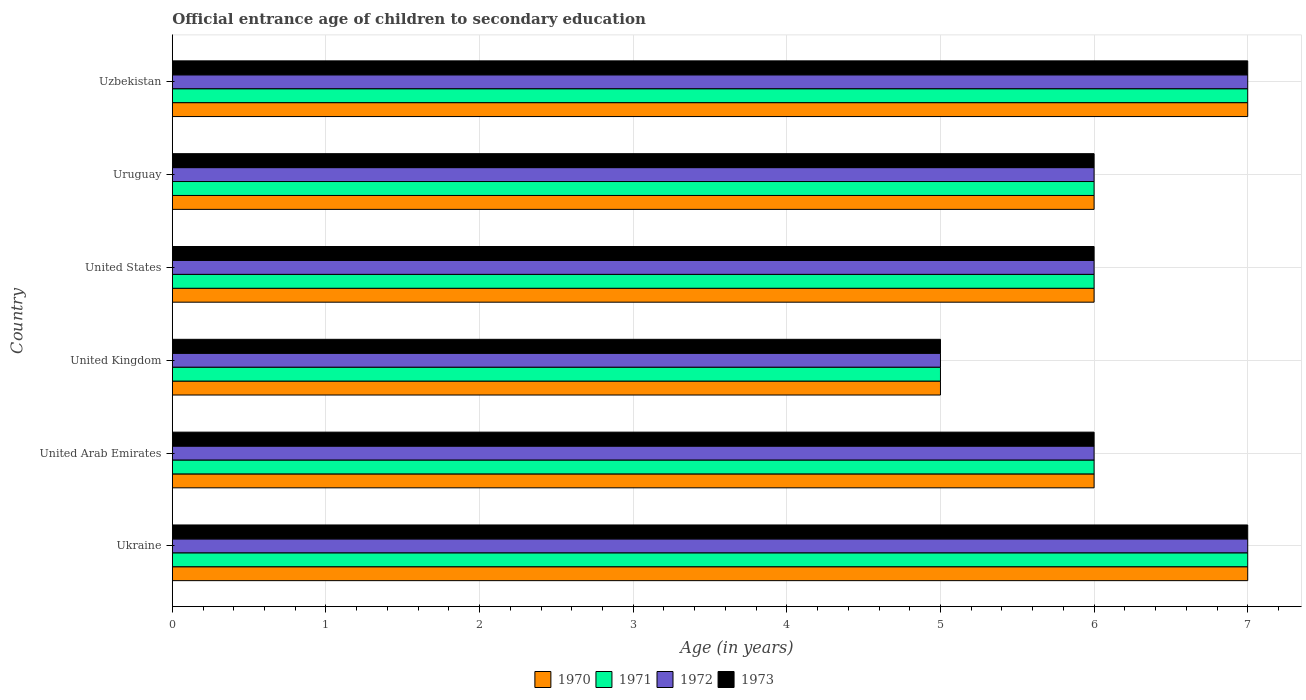Are the number of bars on each tick of the Y-axis equal?
Ensure brevity in your answer.  Yes. How many bars are there on the 4th tick from the top?
Ensure brevity in your answer.  4. How many bars are there on the 6th tick from the bottom?
Offer a terse response. 4. What is the label of the 2nd group of bars from the top?
Your answer should be very brief. Uruguay. In how many cases, is the number of bars for a given country not equal to the number of legend labels?
Make the answer very short. 0. Across all countries, what is the minimum secondary school starting age of children in 1973?
Offer a very short reply. 5. In which country was the secondary school starting age of children in 1971 maximum?
Provide a succinct answer. Ukraine. What is the difference between the secondary school starting age of children in 1972 in United Kingdom and that in Uruguay?
Provide a short and direct response. -1. What is the average secondary school starting age of children in 1972 per country?
Your response must be concise. 6.17. In how many countries, is the secondary school starting age of children in 1971 greater than 5.8 years?
Give a very brief answer. 5. What is the ratio of the secondary school starting age of children in 1973 in Ukraine to that in United States?
Give a very brief answer. 1.17. Is the difference between the secondary school starting age of children in 1970 in United Arab Emirates and Uruguay greater than the difference between the secondary school starting age of children in 1971 in United Arab Emirates and Uruguay?
Give a very brief answer. No. What is the difference between the highest and the second highest secondary school starting age of children in 1970?
Your answer should be compact. 0. Is the sum of the secondary school starting age of children in 1972 in United Kingdom and Uzbekistan greater than the maximum secondary school starting age of children in 1971 across all countries?
Offer a very short reply. Yes. What does the 1st bar from the top in Uzbekistan represents?
Make the answer very short. 1973. What does the 1st bar from the bottom in Ukraine represents?
Your answer should be very brief. 1970. Is it the case that in every country, the sum of the secondary school starting age of children in 1970 and secondary school starting age of children in 1972 is greater than the secondary school starting age of children in 1971?
Provide a succinct answer. Yes. How many bars are there?
Provide a succinct answer. 24. Are the values on the major ticks of X-axis written in scientific E-notation?
Your response must be concise. No. Where does the legend appear in the graph?
Provide a succinct answer. Bottom center. How many legend labels are there?
Ensure brevity in your answer.  4. How are the legend labels stacked?
Your response must be concise. Horizontal. What is the title of the graph?
Ensure brevity in your answer.  Official entrance age of children to secondary education. What is the label or title of the X-axis?
Your response must be concise. Age (in years). What is the Age (in years) in 1970 in Ukraine?
Ensure brevity in your answer.  7. What is the Age (in years) in 1970 in United Arab Emirates?
Make the answer very short. 6. What is the Age (in years) of 1971 in United Arab Emirates?
Provide a succinct answer. 6. What is the Age (in years) of 1972 in United Arab Emirates?
Provide a succinct answer. 6. What is the Age (in years) in 1971 in United Kingdom?
Provide a succinct answer. 5. What is the Age (in years) in 1970 in United States?
Make the answer very short. 6. What is the Age (in years) in 1971 in United States?
Keep it short and to the point. 6. What is the Age (in years) of 1970 in Uruguay?
Ensure brevity in your answer.  6. What is the Age (in years) of 1973 in Uruguay?
Offer a very short reply. 6. What is the Age (in years) in 1971 in Uzbekistan?
Your answer should be compact. 7. What is the Age (in years) in 1972 in Uzbekistan?
Provide a succinct answer. 7. Across all countries, what is the maximum Age (in years) in 1971?
Make the answer very short. 7. Across all countries, what is the maximum Age (in years) in 1972?
Ensure brevity in your answer.  7. Across all countries, what is the minimum Age (in years) in 1973?
Ensure brevity in your answer.  5. What is the difference between the Age (in years) in 1970 in Ukraine and that in United Arab Emirates?
Your answer should be compact. 1. What is the difference between the Age (in years) of 1972 in Ukraine and that in United Arab Emirates?
Ensure brevity in your answer.  1. What is the difference between the Age (in years) in 1970 in Ukraine and that in United Kingdom?
Your answer should be very brief. 2. What is the difference between the Age (in years) in 1971 in Ukraine and that in United Kingdom?
Offer a terse response. 2. What is the difference between the Age (in years) in 1970 in Ukraine and that in United States?
Keep it short and to the point. 1. What is the difference between the Age (in years) in 1971 in Ukraine and that in United States?
Provide a short and direct response. 1. What is the difference between the Age (in years) in 1972 in Ukraine and that in United States?
Offer a terse response. 1. What is the difference between the Age (in years) in 1973 in Ukraine and that in United States?
Make the answer very short. 1. What is the difference between the Age (in years) of 1970 in Ukraine and that in Uruguay?
Give a very brief answer. 1. What is the difference between the Age (in years) of 1971 in Ukraine and that in Uruguay?
Offer a very short reply. 1. What is the difference between the Age (in years) of 1972 in Ukraine and that in Uruguay?
Keep it short and to the point. 1. What is the difference between the Age (in years) in 1973 in Ukraine and that in Uruguay?
Offer a very short reply. 1. What is the difference between the Age (in years) of 1971 in Ukraine and that in Uzbekistan?
Make the answer very short. 0. What is the difference between the Age (in years) in 1972 in Ukraine and that in Uzbekistan?
Give a very brief answer. 0. What is the difference between the Age (in years) of 1973 in Ukraine and that in Uzbekistan?
Provide a succinct answer. 0. What is the difference between the Age (in years) in 1970 in United Arab Emirates and that in United Kingdom?
Ensure brevity in your answer.  1. What is the difference between the Age (in years) in 1972 in United Arab Emirates and that in United Kingdom?
Provide a succinct answer. 1. What is the difference between the Age (in years) of 1973 in United Arab Emirates and that in United Kingdom?
Your answer should be very brief. 1. What is the difference between the Age (in years) of 1970 in United Arab Emirates and that in United States?
Your answer should be compact. 0. What is the difference between the Age (in years) of 1973 in United Arab Emirates and that in Uruguay?
Provide a succinct answer. 0. What is the difference between the Age (in years) of 1970 in United Arab Emirates and that in Uzbekistan?
Your answer should be compact. -1. What is the difference between the Age (in years) in 1971 in United Arab Emirates and that in Uzbekistan?
Keep it short and to the point. -1. What is the difference between the Age (in years) in 1972 in United Arab Emirates and that in Uzbekistan?
Give a very brief answer. -1. What is the difference between the Age (in years) of 1971 in United Kingdom and that in United States?
Keep it short and to the point. -1. What is the difference between the Age (in years) in 1972 in United Kingdom and that in United States?
Your answer should be compact. -1. What is the difference between the Age (in years) in 1973 in United Kingdom and that in United States?
Provide a short and direct response. -1. What is the difference between the Age (in years) in 1970 in United Kingdom and that in Uruguay?
Ensure brevity in your answer.  -1. What is the difference between the Age (in years) of 1972 in United Kingdom and that in Uruguay?
Ensure brevity in your answer.  -1. What is the difference between the Age (in years) in 1973 in United Kingdom and that in Uruguay?
Your answer should be compact. -1. What is the difference between the Age (in years) of 1973 in United States and that in Uruguay?
Make the answer very short. 0. What is the difference between the Age (in years) of 1971 in United States and that in Uzbekistan?
Give a very brief answer. -1. What is the difference between the Age (in years) in 1973 in United States and that in Uzbekistan?
Offer a terse response. -1. What is the difference between the Age (in years) in 1971 in Uruguay and that in Uzbekistan?
Give a very brief answer. -1. What is the difference between the Age (in years) of 1973 in Uruguay and that in Uzbekistan?
Keep it short and to the point. -1. What is the difference between the Age (in years) in 1970 in Ukraine and the Age (in years) in 1971 in United Kingdom?
Keep it short and to the point. 2. What is the difference between the Age (in years) of 1970 in Ukraine and the Age (in years) of 1972 in United Kingdom?
Your answer should be very brief. 2. What is the difference between the Age (in years) in 1971 in Ukraine and the Age (in years) in 1972 in United Kingdom?
Provide a succinct answer. 2. What is the difference between the Age (in years) of 1972 in Ukraine and the Age (in years) of 1973 in United Kingdom?
Ensure brevity in your answer.  2. What is the difference between the Age (in years) of 1970 in Ukraine and the Age (in years) of 1971 in United States?
Make the answer very short. 1. What is the difference between the Age (in years) in 1971 in Ukraine and the Age (in years) in 1972 in United States?
Make the answer very short. 1. What is the difference between the Age (in years) of 1971 in Ukraine and the Age (in years) of 1973 in United States?
Your answer should be very brief. 1. What is the difference between the Age (in years) in 1970 in Ukraine and the Age (in years) in 1972 in Uruguay?
Give a very brief answer. 1. What is the difference between the Age (in years) of 1971 in Ukraine and the Age (in years) of 1972 in Uruguay?
Give a very brief answer. 1. What is the difference between the Age (in years) in 1971 in Ukraine and the Age (in years) in 1973 in Uruguay?
Your answer should be compact. 1. What is the difference between the Age (in years) in 1972 in Ukraine and the Age (in years) in 1973 in Uruguay?
Offer a terse response. 1. What is the difference between the Age (in years) in 1972 in Ukraine and the Age (in years) in 1973 in Uzbekistan?
Offer a very short reply. 0. What is the difference between the Age (in years) of 1970 in United Arab Emirates and the Age (in years) of 1971 in United Kingdom?
Your answer should be very brief. 1. What is the difference between the Age (in years) in 1970 in United Arab Emirates and the Age (in years) in 1972 in United Kingdom?
Ensure brevity in your answer.  1. What is the difference between the Age (in years) of 1971 in United Arab Emirates and the Age (in years) of 1972 in United Kingdom?
Give a very brief answer. 1. What is the difference between the Age (in years) of 1971 in United Arab Emirates and the Age (in years) of 1973 in United Kingdom?
Keep it short and to the point. 1. What is the difference between the Age (in years) of 1972 in United Arab Emirates and the Age (in years) of 1973 in United Kingdom?
Your answer should be very brief. 1. What is the difference between the Age (in years) in 1970 in United Arab Emirates and the Age (in years) in 1972 in United States?
Your response must be concise. 0. What is the difference between the Age (in years) in 1971 in United Arab Emirates and the Age (in years) in 1972 in United States?
Your answer should be compact. 0. What is the difference between the Age (in years) in 1970 in United Arab Emirates and the Age (in years) in 1971 in Uruguay?
Your answer should be compact. 0. What is the difference between the Age (in years) in 1970 in United Arab Emirates and the Age (in years) in 1973 in Uruguay?
Provide a succinct answer. 0. What is the difference between the Age (in years) in 1971 in United Arab Emirates and the Age (in years) in 1972 in Uruguay?
Keep it short and to the point. 0. What is the difference between the Age (in years) in 1972 in United Arab Emirates and the Age (in years) in 1973 in Uruguay?
Your answer should be compact. 0. What is the difference between the Age (in years) in 1970 in United Arab Emirates and the Age (in years) in 1971 in Uzbekistan?
Ensure brevity in your answer.  -1. What is the difference between the Age (in years) of 1971 in United Arab Emirates and the Age (in years) of 1973 in Uzbekistan?
Offer a very short reply. -1. What is the difference between the Age (in years) in 1970 in United Kingdom and the Age (in years) in 1971 in United States?
Make the answer very short. -1. What is the difference between the Age (in years) in 1970 in United Kingdom and the Age (in years) in 1972 in United States?
Give a very brief answer. -1. What is the difference between the Age (in years) in 1970 in United Kingdom and the Age (in years) in 1973 in United States?
Provide a short and direct response. -1. What is the difference between the Age (in years) in 1971 in United Kingdom and the Age (in years) in 1972 in United States?
Your answer should be very brief. -1. What is the difference between the Age (in years) in 1971 in United Kingdom and the Age (in years) in 1973 in United States?
Provide a short and direct response. -1. What is the difference between the Age (in years) in 1972 in United Kingdom and the Age (in years) in 1973 in United States?
Offer a terse response. -1. What is the difference between the Age (in years) in 1970 in United Kingdom and the Age (in years) in 1973 in Uruguay?
Provide a succinct answer. -1. What is the difference between the Age (in years) of 1971 in United Kingdom and the Age (in years) of 1972 in Uruguay?
Ensure brevity in your answer.  -1. What is the difference between the Age (in years) of 1971 in United Kingdom and the Age (in years) of 1973 in Uruguay?
Make the answer very short. -1. What is the difference between the Age (in years) of 1970 in United Kingdom and the Age (in years) of 1971 in Uzbekistan?
Your answer should be very brief. -2. What is the difference between the Age (in years) of 1970 in United Kingdom and the Age (in years) of 1972 in Uzbekistan?
Keep it short and to the point. -2. What is the difference between the Age (in years) of 1971 in United Kingdom and the Age (in years) of 1972 in Uzbekistan?
Your answer should be compact. -2. What is the difference between the Age (in years) of 1971 in United Kingdom and the Age (in years) of 1973 in Uzbekistan?
Offer a terse response. -2. What is the difference between the Age (in years) of 1972 in United Kingdom and the Age (in years) of 1973 in Uzbekistan?
Keep it short and to the point. -2. What is the difference between the Age (in years) of 1970 in United States and the Age (in years) of 1971 in Uruguay?
Provide a short and direct response. 0. What is the difference between the Age (in years) of 1971 in United States and the Age (in years) of 1972 in Uruguay?
Keep it short and to the point. 0. What is the difference between the Age (in years) of 1971 in United States and the Age (in years) of 1972 in Uzbekistan?
Your answer should be very brief. -1. What is the difference between the Age (in years) in 1971 in United States and the Age (in years) in 1973 in Uzbekistan?
Provide a succinct answer. -1. What is the difference between the Age (in years) of 1970 in Uruguay and the Age (in years) of 1971 in Uzbekistan?
Your response must be concise. -1. What is the difference between the Age (in years) in 1970 in Uruguay and the Age (in years) in 1972 in Uzbekistan?
Keep it short and to the point. -1. What is the difference between the Age (in years) in 1972 in Uruguay and the Age (in years) in 1973 in Uzbekistan?
Your answer should be compact. -1. What is the average Age (in years) in 1970 per country?
Provide a succinct answer. 6.17. What is the average Age (in years) in 1971 per country?
Provide a succinct answer. 6.17. What is the average Age (in years) in 1972 per country?
Ensure brevity in your answer.  6.17. What is the average Age (in years) of 1973 per country?
Offer a terse response. 6.17. What is the difference between the Age (in years) of 1970 and Age (in years) of 1971 in Ukraine?
Give a very brief answer. 0. What is the difference between the Age (in years) in 1970 and Age (in years) in 1972 in Ukraine?
Offer a terse response. 0. What is the difference between the Age (in years) in 1971 and Age (in years) in 1973 in Ukraine?
Provide a succinct answer. 0. What is the difference between the Age (in years) of 1972 and Age (in years) of 1973 in Ukraine?
Provide a succinct answer. 0. What is the difference between the Age (in years) in 1970 and Age (in years) in 1971 in United Arab Emirates?
Make the answer very short. 0. What is the difference between the Age (in years) of 1970 and Age (in years) of 1972 in United Arab Emirates?
Your answer should be compact. 0. What is the difference between the Age (in years) of 1971 and Age (in years) of 1972 in United Arab Emirates?
Ensure brevity in your answer.  0. What is the difference between the Age (in years) in 1971 and Age (in years) in 1973 in United Arab Emirates?
Ensure brevity in your answer.  0. What is the difference between the Age (in years) of 1972 and Age (in years) of 1973 in United Arab Emirates?
Your response must be concise. 0. What is the difference between the Age (in years) of 1970 and Age (in years) of 1971 in United Kingdom?
Provide a short and direct response. 0. What is the difference between the Age (in years) of 1970 and Age (in years) of 1972 in United Kingdom?
Your response must be concise. 0. What is the difference between the Age (in years) in 1970 and Age (in years) in 1973 in United Kingdom?
Offer a terse response. 0. What is the difference between the Age (in years) of 1970 and Age (in years) of 1971 in United States?
Provide a short and direct response. 0. What is the difference between the Age (in years) in 1970 and Age (in years) in 1972 in United States?
Offer a terse response. 0. What is the difference between the Age (in years) in 1971 and Age (in years) in 1972 in United States?
Your response must be concise. 0. What is the difference between the Age (in years) of 1971 and Age (in years) of 1973 in United States?
Your response must be concise. 0. What is the difference between the Age (in years) of 1972 and Age (in years) of 1973 in United States?
Your answer should be very brief. 0. What is the difference between the Age (in years) in 1970 and Age (in years) in 1971 in Uruguay?
Provide a succinct answer. 0. What is the difference between the Age (in years) of 1972 and Age (in years) of 1973 in Uruguay?
Your answer should be compact. 0. What is the difference between the Age (in years) of 1970 and Age (in years) of 1971 in Uzbekistan?
Ensure brevity in your answer.  0. What is the difference between the Age (in years) of 1971 and Age (in years) of 1972 in Uzbekistan?
Your answer should be very brief. 0. What is the ratio of the Age (in years) in 1971 in Ukraine to that in United Arab Emirates?
Provide a succinct answer. 1.17. What is the ratio of the Age (in years) of 1971 in Ukraine to that in United Kingdom?
Offer a terse response. 1.4. What is the ratio of the Age (in years) of 1972 in Ukraine to that in United Kingdom?
Your response must be concise. 1.4. What is the ratio of the Age (in years) in 1973 in Ukraine to that in United Kingdom?
Offer a terse response. 1.4. What is the ratio of the Age (in years) of 1970 in Ukraine to that in United States?
Your answer should be compact. 1.17. What is the ratio of the Age (in years) in 1972 in Ukraine to that in United States?
Keep it short and to the point. 1.17. What is the ratio of the Age (in years) of 1970 in Ukraine to that in Uruguay?
Offer a very short reply. 1.17. What is the ratio of the Age (in years) of 1971 in Ukraine to that in Uruguay?
Give a very brief answer. 1.17. What is the ratio of the Age (in years) of 1972 in Ukraine to that in Uruguay?
Your response must be concise. 1.17. What is the ratio of the Age (in years) in 1973 in Ukraine to that in Uruguay?
Your answer should be very brief. 1.17. What is the ratio of the Age (in years) of 1971 in Ukraine to that in Uzbekistan?
Your answer should be compact. 1. What is the ratio of the Age (in years) in 1973 in Ukraine to that in Uzbekistan?
Offer a terse response. 1. What is the ratio of the Age (in years) of 1971 in United Arab Emirates to that in United Kingdom?
Offer a very short reply. 1.2. What is the ratio of the Age (in years) in 1972 in United Arab Emirates to that in United Kingdom?
Make the answer very short. 1.2. What is the ratio of the Age (in years) of 1973 in United Arab Emirates to that in United Kingdom?
Provide a short and direct response. 1.2. What is the ratio of the Age (in years) in 1970 in United Arab Emirates to that in United States?
Make the answer very short. 1. What is the ratio of the Age (in years) in 1971 in United Arab Emirates to that in United States?
Offer a terse response. 1. What is the ratio of the Age (in years) in 1971 in United Arab Emirates to that in Uruguay?
Provide a succinct answer. 1. What is the ratio of the Age (in years) in 1973 in United Arab Emirates to that in Uruguay?
Your response must be concise. 1. What is the ratio of the Age (in years) of 1970 in United Arab Emirates to that in Uzbekistan?
Provide a short and direct response. 0.86. What is the ratio of the Age (in years) in 1973 in United Arab Emirates to that in Uzbekistan?
Offer a terse response. 0.86. What is the ratio of the Age (in years) of 1970 in United Kingdom to that in United States?
Your response must be concise. 0.83. What is the ratio of the Age (in years) of 1972 in United Kingdom to that in United States?
Your answer should be compact. 0.83. What is the ratio of the Age (in years) of 1973 in United Kingdom to that in United States?
Ensure brevity in your answer.  0.83. What is the ratio of the Age (in years) of 1971 in United Kingdom to that in Uruguay?
Provide a succinct answer. 0.83. What is the ratio of the Age (in years) in 1973 in United Kingdom to that in Uruguay?
Keep it short and to the point. 0.83. What is the ratio of the Age (in years) of 1970 in United Kingdom to that in Uzbekistan?
Your response must be concise. 0.71. What is the ratio of the Age (in years) in 1972 in United Kingdom to that in Uzbekistan?
Ensure brevity in your answer.  0.71. What is the ratio of the Age (in years) of 1970 in United States to that in Uruguay?
Provide a succinct answer. 1. What is the ratio of the Age (in years) of 1972 in United States to that in Uruguay?
Offer a very short reply. 1. What is the ratio of the Age (in years) of 1972 in United States to that in Uzbekistan?
Offer a terse response. 0.86. What is the ratio of the Age (in years) of 1970 in Uruguay to that in Uzbekistan?
Offer a very short reply. 0.86. What is the ratio of the Age (in years) in 1972 in Uruguay to that in Uzbekistan?
Ensure brevity in your answer.  0.86. What is the difference between the highest and the second highest Age (in years) of 1970?
Ensure brevity in your answer.  0. What is the difference between the highest and the second highest Age (in years) of 1971?
Make the answer very short. 0. What is the difference between the highest and the lowest Age (in years) of 1970?
Provide a short and direct response. 2. What is the difference between the highest and the lowest Age (in years) of 1971?
Offer a terse response. 2. What is the difference between the highest and the lowest Age (in years) in 1972?
Provide a short and direct response. 2. 